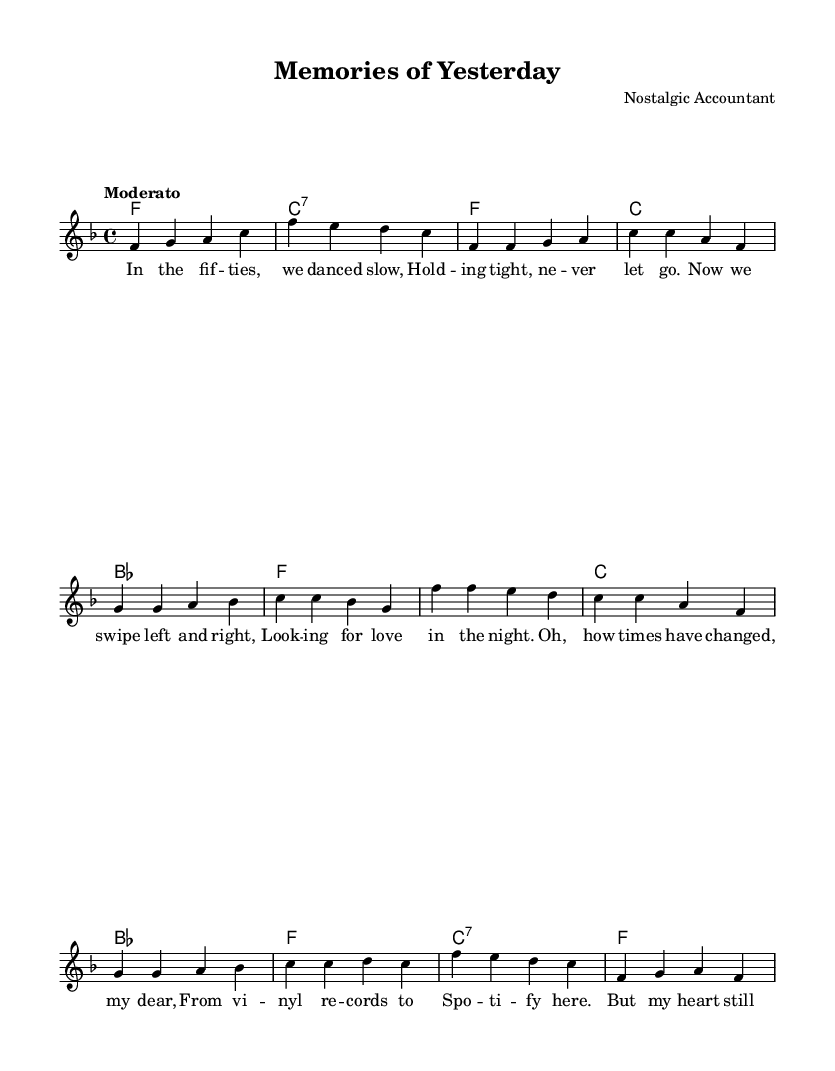What is the key signature of this music? The key signature is F major, which has one flat (B flat). This can be determined by looking at the key signature symbols at the beginning of the staff.
Answer: F major What is the time signature of this music? The time signature is 4/4, which indicates that there are four beats in each measure and a quarter note receives one beat. This is indicated at the start of the music on the staff.
Answer: 4/4 What is the tempo marking for this piece? The tempo marking is "Moderato," which suggests a moderate speed for the piece. This is typically found above the first bar of music.
Answer: Moderato How many measures are in the chorus section? The chorus section consists of four measures, as indicated by the grouping of notes and bar lines spanning that part of the music.
Answer: Four measures Explain the emotional contrast between the past and present as suggested in the lyrics. The lyrics illustrate a nostalgic fondness for slow dancing in the past ("In the fifties, we danced slow") contrasted with the modern experience of digital dating ("Now we swipe left and right"). This shows a shift from genuine romantic connection to a more superficial interaction in today's relationships. The emotional tone is both sentimental and somewhat critical of modern romance.
Answer: A contrast between genuine connection and superficial interactions What instrument is this score likely arranged for? Given the notation and the structure of the score with a melody and chords, it is most likely arranged for piano or a similar harmonic instrument that can play both melodies and chords simultaneously.
Answer: Piano 